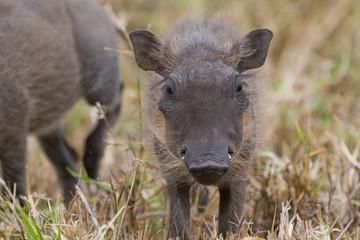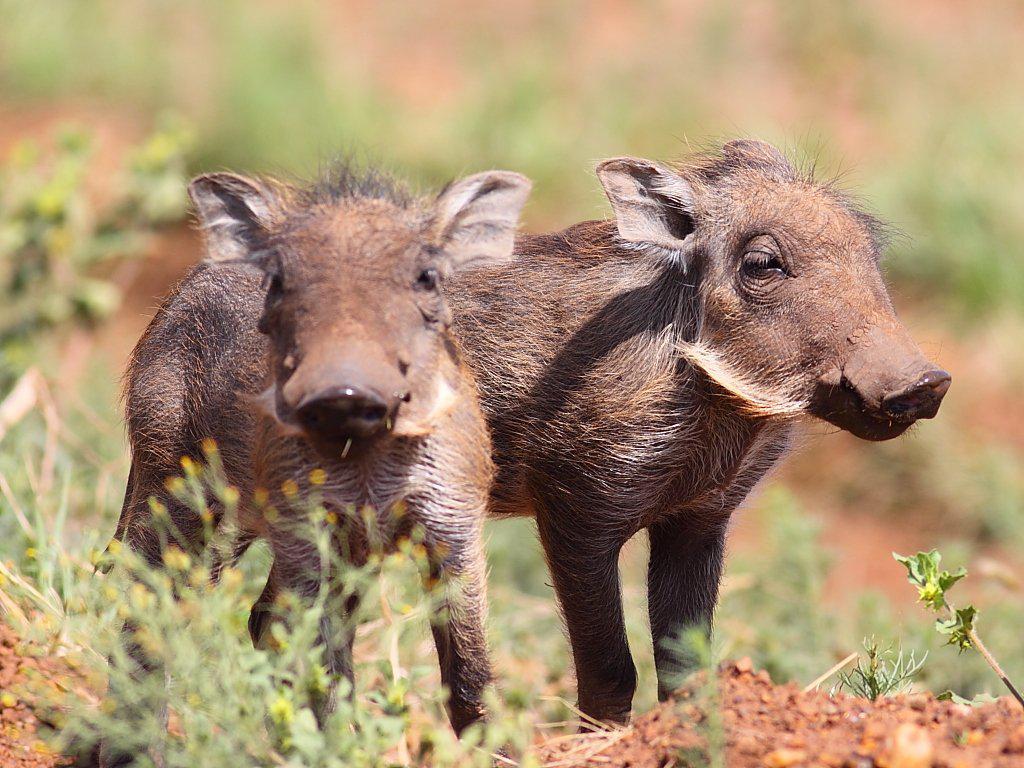The first image is the image on the left, the second image is the image on the right. For the images displayed, is the sentence "The right image contains no more than two wart hogs." factually correct? Answer yes or no. Yes. The first image is the image on the left, the second image is the image on the right. Given the left and right images, does the statement "At least one warthog is wading in mud in one of the images." hold true? Answer yes or no. No. 